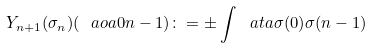<formula> <loc_0><loc_0><loc_500><loc_500>Y _ { n + 1 } ( \sigma _ { n } ) ( \ a o a { 0 } { n - 1 } ) \colon = \pm \int \ a t a { \sigma ( 0 ) } { \sigma ( n - 1 ) }</formula> 